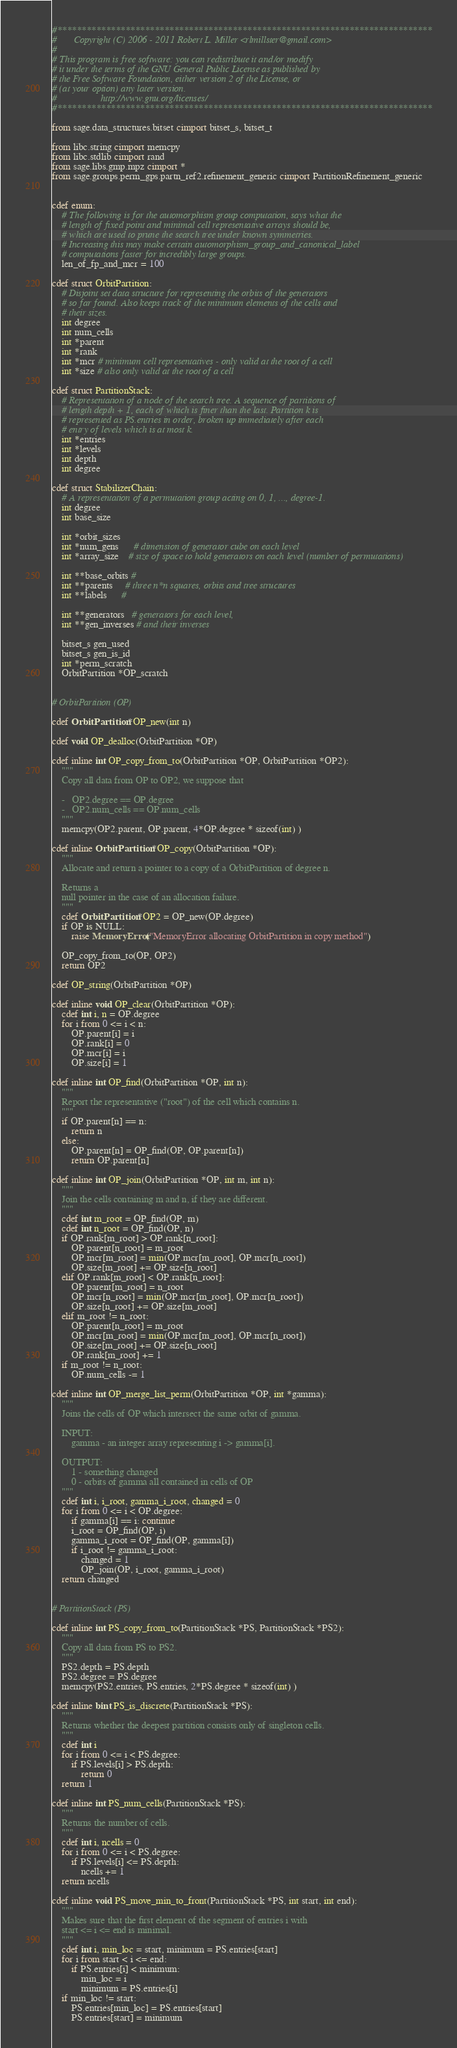Convert code to text. <code><loc_0><loc_0><loc_500><loc_500><_Cython_>#*****************************************************************************
#       Copyright (C) 2006 - 2011 Robert L. Miller <rlmillster@gmail.com>
#
# This program is free software: you can redistribute it and/or modify
# it under the terms of the GNU General Public License as published by
# the Free Software Foundation, either version 2 of the License, or
# (at your option) any later version.
#                  http://www.gnu.org/licenses/
#*****************************************************************************

from sage.data_structures.bitset cimport bitset_s, bitset_t

from libc.string cimport memcpy
from libc.stdlib cimport rand
from sage.libs.gmp.mpz cimport *
from sage.groups.perm_gps.partn_ref2.refinement_generic cimport PartitionRefinement_generic


cdef enum:
    # The following is for the automorphism group computation, says what the
    # length of fixed point and minimal cell representative arrays should be,
    # which are used to prune the search tree under known symmetries.
    # Increasing this may make certain automorphism_group_and_canonical_label
    # computations faster for incredibly large groups.
    len_of_fp_and_mcr = 100

cdef struct OrbitPartition:
    # Disjoint set data structure for representing the orbits of the generators
    # so far found. Also keeps track of the minimum elements of the cells and
    # their sizes.
    int degree
    int num_cells
    int *parent
    int *rank
    int *mcr # minimum cell representatives - only valid at the root of a cell
    int *size # also only valid at the root of a cell

cdef struct PartitionStack:
    # Representation of a node of the search tree. A sequence of partitions of
    # length depth + 1, each of which is finer than the last. Partition k is
    # represented as PS.entries in order, broken up immediately after each
    # entry of levels which is at most k.
    int *entries
    int *levels
    int depth
    int degree

cdef struct StabilizerChain:
    # A representation of a permutation group acting on 0, 1, ..., degree-1.
    int degree
    int base_size

    int *orbit_sizes
    int *num_gens      # dimension of generator cube on each level
    int *array_size    # size of space to hold generators on each level (number of permutations)

    int **base_orbits #
    int **parents     # three n*n squares, orbits and tree structures
    int **labels      #

    int **generators   # generators for each level,
    int **gen_inverses # and their inverses

    bitset_s gen_used
    bitset_s gen_is_id
    int *perm_scratch
    OrbitPartition *OP_scratch


# OrbitPartition (OP)

cdef OrbitPartition *OP_new(int n)

cdef void OP_dealloc(OrbitPartition *OP)

cdef inline int OP_copy_from_to(OrbitPartition *OP, OrbitPartition *OP2):
    """
    Copy all data from OP to OP2, we suppose that

    -   OP2.degree == OP.degree
    -   OP2.num_cells == OP.num_cells
    """
    memcpy(OP2.parent, OP.parent, 4*OP.degree * sizeof(int) )

cdef inline OrbitPartition *OP_copy(OrbitPartition *OP):
    """
    Allocate and return a pointer to a copy of a OrbitPartition of degree n.

    Returns a
    null pointer in the case of an allocation failure.
    """
    cdef OrbitPartition *OP2 = OP_new(OP.degree)
    if OP is NULL:
        raise MemoryError("MemoryError allocating OrbitPartition in copy method")

    OP_copy_from_to(OP, OP2)
    return OP2

cdef OP_string(OrbitPartition *OP)

cdef inline void OP_clear(OrbitPartition *OP):
    cdef int i, n = OP.degree
    for i from 0 <= i < n:
        OP.parent[i] = i
        OP.rank[i] = 0
        OP.mcr[i] = i
        OP.size[i] = 1

cdef inline int OP_find(OrbitPartition *OP, int n):
    """
    Report the representative ("root") of the cell which contains n.
    """
    if OP.parent[n] == n:
        return n
    else:
        OP.parent[n] = OP_find(OP, OP.parent[n])
        return OP.parent[n]

cdef inline int OP_join(OrbitPartition *OP, int m, int n):
    """
    Join the cells containing m and n, if they are different.
    """
    cdef int m_root = OP_find(OP, m)
    cdef int n_root = OP_find(OP, n)
    if OP.rank[m_root] > OP.rank[n_root]:
        OP.parent[n_root] = m_root
        OP.mcr[m_root] = min(OP.mcr[m_root], OP.mcr[n_root])
        OP.size[m_root] += OP.size[n_root]
    elif OP.rank[m_root] < OP.rank[n_root]:
        OP.parent[m_root] = n_root
        OP.mcr[n_root] = min(OP.mcr[m_root], OP.mcr[n_root])
        OP.size[n_root] += OP.size[m_root]
    elif m_root != n_root:
        OP.parent[n_root] = m_root
        OP.mcr[m_root] = min(OP.mcr[m_root], OP.mcr[n_root])
        OP.size[m_root] += OP.size[n_root]
        OP.rank[m_root] += 1
    if m_root != n_root:
        OP.num_cells -= 1

cdef inline int OP_merge_list_perm(OrbitPartition *OP, int *gamma):
    """
    Joins the cells of OP which intersect the same orbit of gamma.

    INPUT:
        gamma - an integer array representing i -> gamma[i].

    OUTPUT:
        1 - something changed
        0 - orbits of gamma all contained in cells of OP
    """
    cdef int i, i_root, gamma_i_root, changed = 0
    for i from 0 <= i < OP.degree:
        if gamma[i] == i: continue
        i_root = OP_find(OP, i)
        gamma_i_root = OP_find(OP, gamma[i])
        if i_root != gamma_i_root:
            changed = 1
            OP_join(OP, i_root, gamma_i_root)
    return changed


# PartitionStack (PS)

cdef inline int PS_copy_from_to(PartitionStack *PS, PartitionStack *PS2):
    """
    Copy all data from PS to PS2.
    """
    PS2.depth = PS.depth
    PS2.degree = PS.degree
    memcpy(PS2.entries, PS.entries, 2*PS.degree * sizeof(int) )

cdef inline bint PS_is_discrete(PartitionStack *PS):
    """
    Returns whether the deepest partition consists only of singleton cells.
    """
    cdef int i
    for i from 0 <= i < PS.degree:
        if PS.levels[i] > PS.depth:
            return 0
    return 1

cdef inline int PS_num_cells(PartitionStack *PS):
    """
    Returns the number of cells.
    """
    cdef int i, ncells = 0
    for i from 0 <= i < PS.degree:
        if PS.levels[i] <= PS.depth:
            ncells += 1
    return ncells

cdef inline void PS_move_min_to_front(PartitionStack *PS, int start, int end):
    """
    Makes sure that the first element of the segment of entries i with
    start <= i <= end is minimal.
    """
    cdef int i, min_loc = start, minimum = PS.entries[start]
    for i from start < i <= end:
        if PS.entries[i] < minimum:
            min_loc = i
            minimum = PS.entries[i]
    if min_loc != start:
        PS.entries[min_loc] = PS.entries[start]
        PS.entries[start] = minimum
</code> 